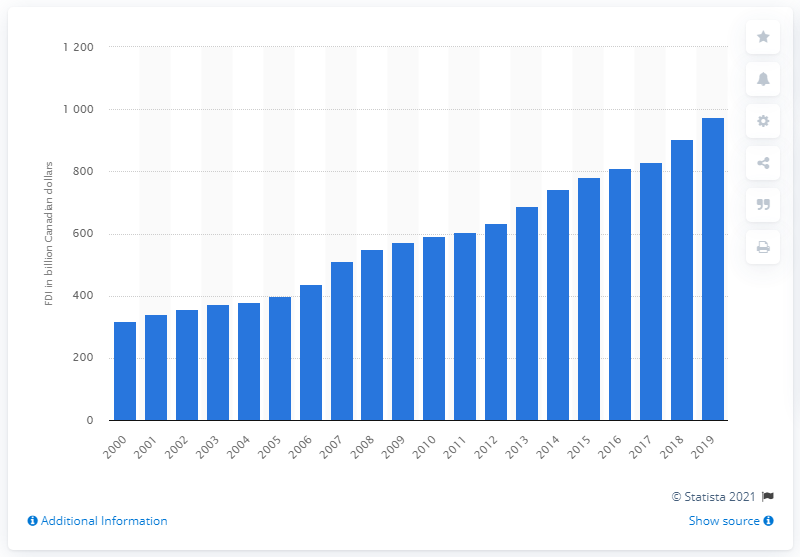Point out several critical features in this image. In 2019, the amount of foreign direct investments in Canada was 973.89. In 2000, the value of foreign direct investments in Canada was 319.12. 